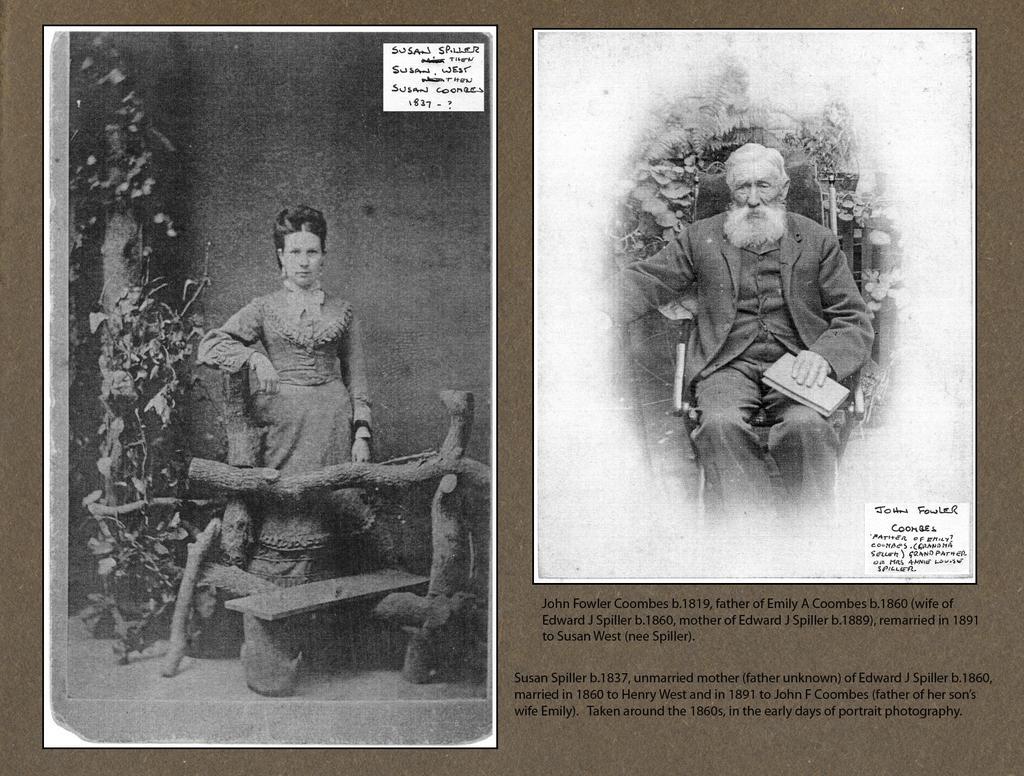Please provide a concise description of this image. We can see poster,on this poster we can see photos of two people and we can see something written on this poster. 